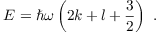<formula> <loc_0><loc_0><loc_500><loc_500>E = \hbar { \omega } \left ( 2 k + l + { \frac { 3 } { 2 } } \right ) .</formula> 